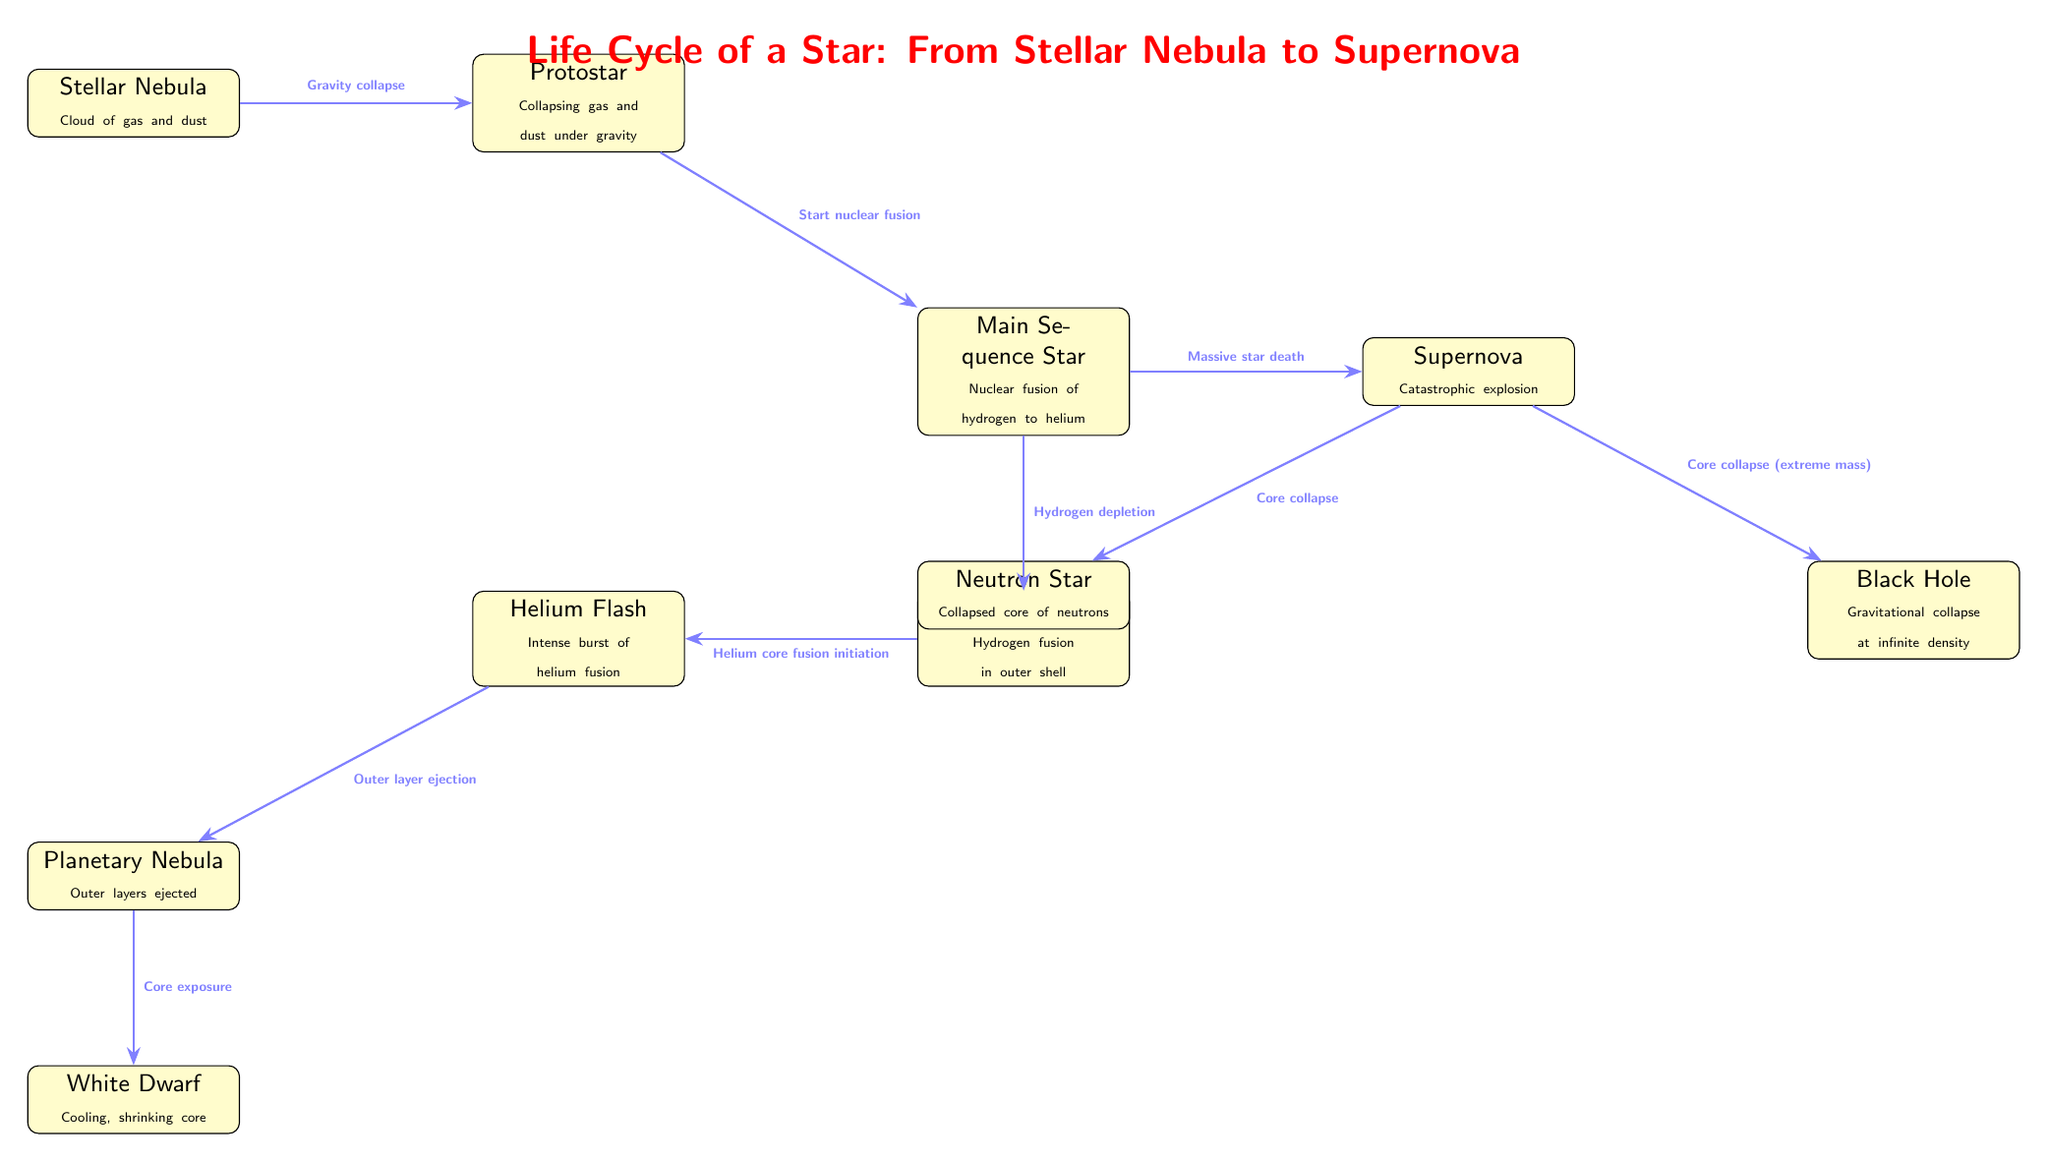What is the first stage of the star's life cycle? The diagram shows that the first node (stage) is labeled "Stellar Nebula," which represents the initial formation of a star from a cloud of gas and dust.
Answer: Stellar Nebula How many stages are there from Stellar Nebula to Black Hole? By counting the nodes displayed in the diagram from "Stellar Nebula" to "Black Hole," there are a total of 9 distinct stages in the life cycle of the star shown in the diagram.
Answer: 9 Which stage follows the Red Giant? The diagram indicates that "Helium Flash" follows the "Red Giant" stage, as shown by the arrow connecting these two nodes.
Answer: Helium Flash What physical process marks the transition from Protostar to Main Sequence Star? The diagram states that the transition from "Protostar" to "Main Sequence Star" is marked by the process of "Start nuclear fusion," highlighting the critical development of the star's core.
Answer: Start nuclear fusion What happens during the Supernova stage? The diagram notes that during the "Supernova" stage, a "Catastrophic explosion" occurs, indicating the dramatic end of certain types of stars.
Answer: Catastrophic explosion What is ejected during the Planetary Nebula stage? The "Planetary Nebula" stage is described in the diagram as the point when the "Outer layers ejected," which represents the outer parts of the star being expelled.
Answer: Outer layers ejected What stage comes after the Supernova for a massive star? The diagram shows two possible outcomes for a massive star after a supernova: it can become either a "Neutron Star" or a "Black Hole," depending on the mass of the core that remains after the explosion.
Answer: Neutron Star or Black Hole What initiates the Helium Flash stage? According to the diagram, "Helium core fusion initiation" is the defining process that begins the "Helium Flash" stage, as indicated by the arrow from "Red Giant" to "Helium Flash."
Answer: Helium core fusion initiation Which process is involved in the death of a massive star? The diagram specifies that the "Massive star death" leads to the "Supernova" stage, indicating that this process is crucial in the life cycle of a massive star.
Answer: Massive star death 